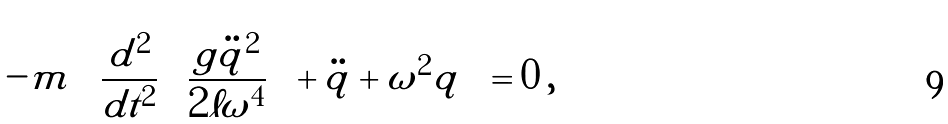<formula> <loc_0><loc_0><loc_500><loc_500>- m \left [ \frac { d ^ { 2 } } { d t ^ { 2 } } \left ( \frac { g \ddot { q } ^ { 2 } } { 2 \ell \omega ^ { 4 } } \right ) + \ddot { q } + \omega ^ { 2 } q \right ] = 0 \, ,</formula> 